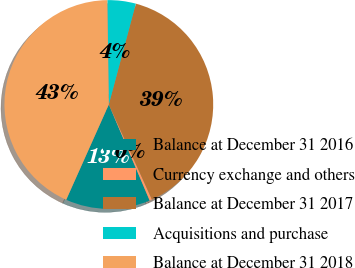Convert chart. <chart><loc_0><loc_0><loc_500><loc_500><pie_chart><fcel>Balance at December 31 2016<fcel>Currency exchange and others<fcel>Balance at December 31 2017<fcel>Acquisitions and purchase<fcel>Balance at December 31 2018<nl><fcel>13.09%<fcel>0.38%<fcel>39.05%<fcel>4.4%<fcel>43.07%<nl></chart> 